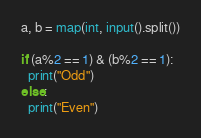Convert code to text. <code><loc_0><loc_0><loc_500><loc_500><_Python_>a, b = map(int, input().split())

if (a%2 == 1) & (b%2 == 1):
  print("Odd")
else:
  print("Even")</code> 